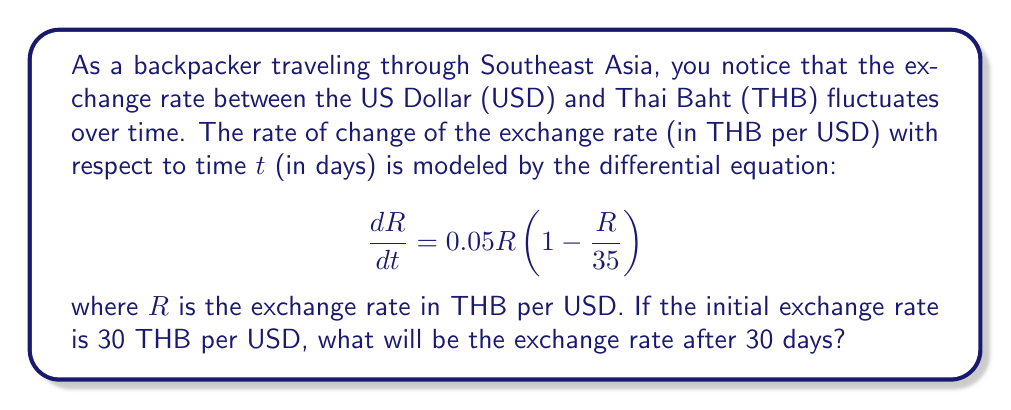Could you help me with this problem? To solve this problem, we need to use the given differential equation and initial condition. This is a logistic growth model.

Step 1: Identify the differential equation and initial condition
- Differential equation: $$\frac{dR}{dt} = 0.05R(1 - \frac{R}{35})$$
- Initial condition: $R(0) = 30$ THB/USD

Step 2: Solve the differential equation
The solution to this logistic equation is:

$$R(t) = \frac{35K}{K + (35 - K)e^{-0.05t}}$$

where K is the initial value of R.

Step 3: Substitute the initial condition
$K = 30$ (initial exchange rate)

$$R(t) = \frac{35 \cdot 30}{30 + (35 - 30)e^{-0.05t}}$$

Step 4: Simplify
$$R(t) = \frac{1050}{30 + 5e^{-0.05t}}$$

Step 5: Calculate the exchange rate after 30 days
Substitute $t = 30$ into the equation:

$$R(30) = \frac{1050}{30 + 5e^{-0.05(30)}}$$

$$R(30) = \frac{1050}{30 + 5e^{-1.5}}$$

$$R(30) = \frac{1050}{30 + 5(0.2231)}$$

$$R(30) = \frac{1050}{31.1155}$$

$$R(30) \approx 33.7456$$

Therefore, after 30 days, the exchange rate will be approximately 33.7456 THB per USD.
Answer: 33.7456 THB/USD 